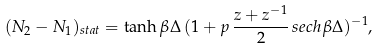Convert formula to latex. <formula><loc_0><loc_0><loc_500><loc_500>( N _ { 2 } - N _ { 1 } ) _ { s t a t } = \tanh \beta \Delta \, ( 1 + p \, \frac { z + z ^ { - 1 } } { 2 } \, s e c h \beta \Delta ) ^ { - 1 } ,</formula> 